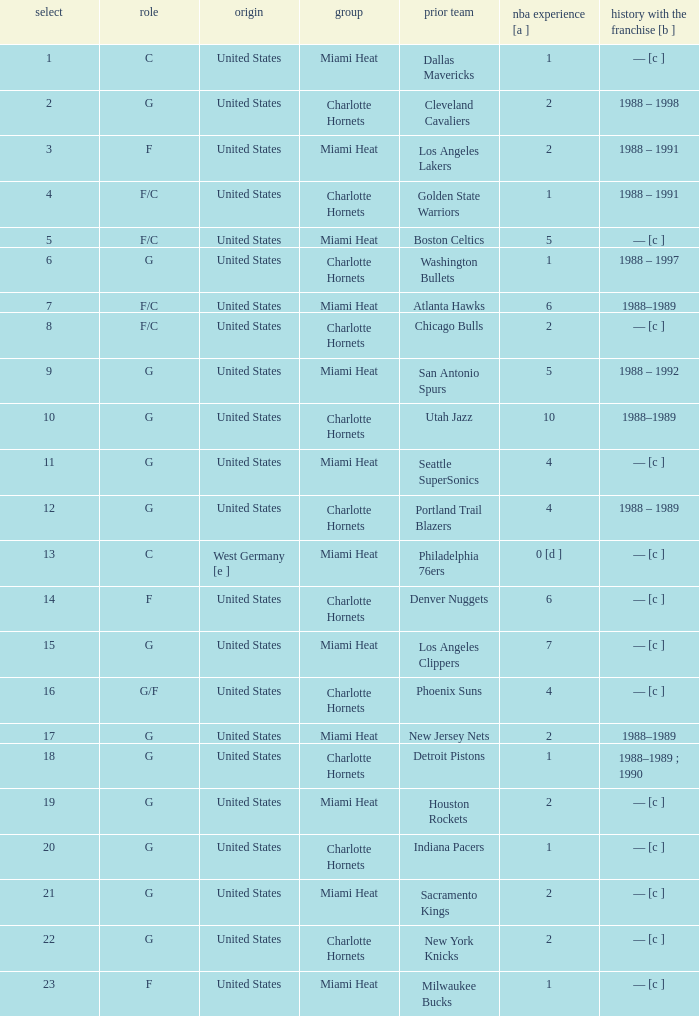What is the team of the player who was previously on the indiana pacers? Charlotte Hornets. 